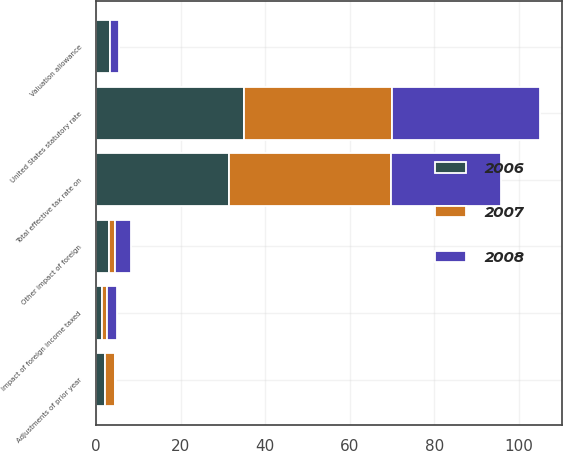Convert chart. <chart><loc_0><loc_0><loc_500><loc_500><stacked_bar_chart><ecel><fcel>United States statutory rate<fcel>Adjustments of prior year<fcel>Impact of foreign income taxed<fcel>Other impact of foreign<fcel>Valuation allowance<fcel>Total effective tax rate on<nl><fcel>2007<fcel>35<fcel>2.3<fcel>1.4<fcel>1.3<fcel>0.1<fcel>38.3<nl><fcel>2008<fcel>35<fcel>0.3<fcel>2.3<fcel>3.9<fcel>2<fcel>26.2<nl><fcel>2006<fcel>35<fcel>2.1<fcel>1.3<fcel>3.1<fcel>3.3<fcel>31.4<nl></chart> 